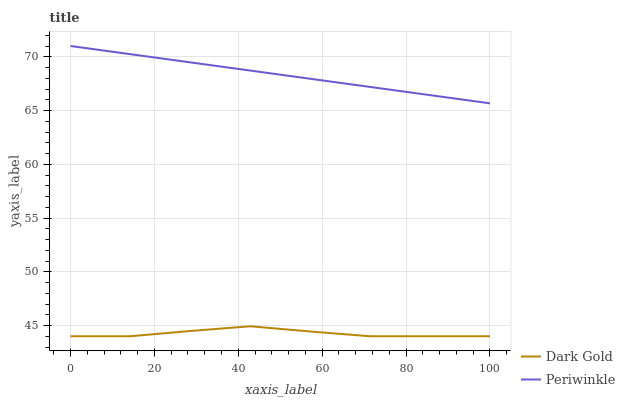Does Dark Gold have the minimum area under the curve?
Answer yes or no. Yes. Does Periwinkle have the maximum area under the curve?
Answer yes or no. Yes. Does Dark Gold have the maximum area under the curve?
Answer yes or no. No. Is Periwinkle the smoothest?
Answer yes or no. Yes. Is Dark Gold the roughest?
Answer yes or no. Yes. Is Dark Gold the smoothest?
Answer yes or no. No. Does Dark Gold have the lowest value?
Answer yes or no. Yes. Does Periwinkle have the highest value?
Answer yes or no. Yes. Does Dark Gold have the highest value?
Answer yes or no. No. Is Dark Gold less than Periwinkle?
Answer yes or no. Yes. Is Periwinkle greater than Dark Gold?
Answer yes or no. Yes. Does Dark Gold intersect Periwinkle?
Answer yes or no. No. 